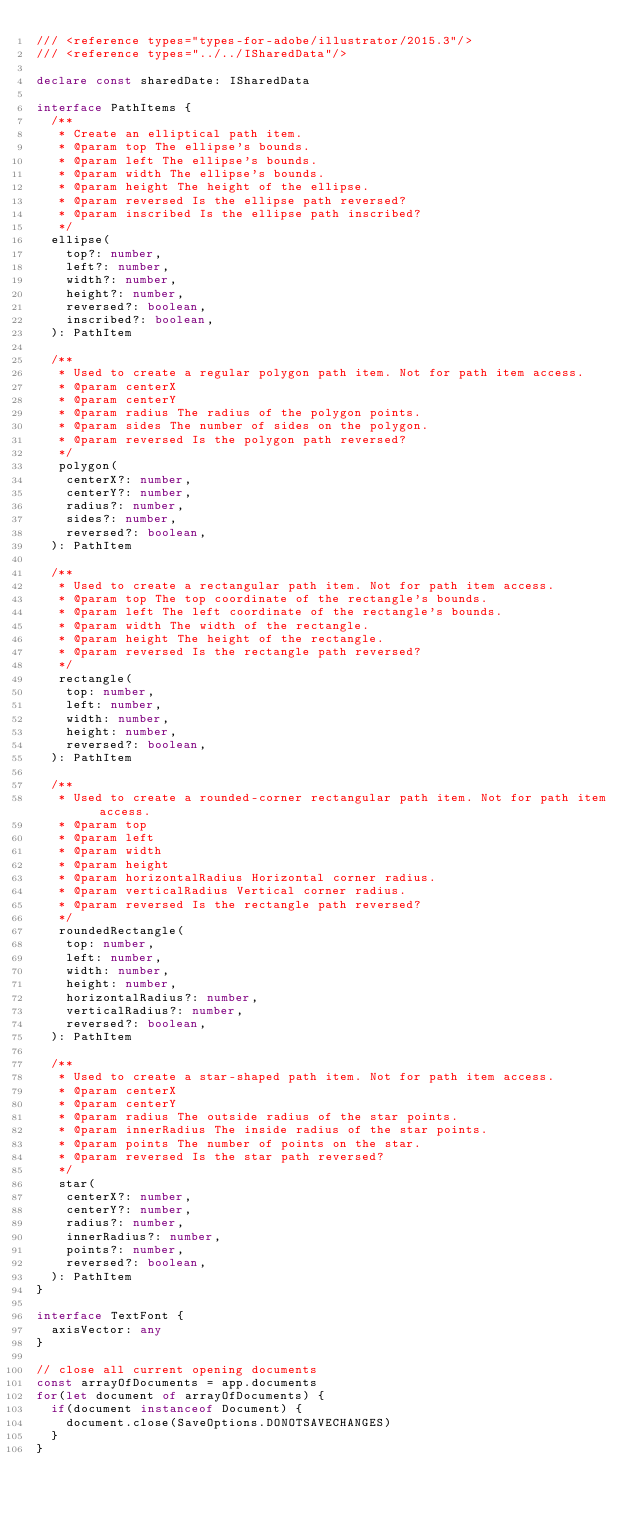<code> <loc_0><loc_0><loc_500><loc_500><_TypeScript_>/// <reference types="types-for-adobe/illustrator/2015.3"/>
/// <reference types="../../ISharedData"/>

declare const sharedDate: ISharedData

interface PathItems {
  /**
   * Create an elliptical path item.
   * @param top The ellipse's bounds.
   * @param left The ellipse's bounds.
   * @param width The ellipse's bounds.
   * @param height The height of the ellipse.
   * @param reversed Is the ellipse path reversed?
   * @param inscribed Is the ellipse path inscribed?
   */
  ellipse(
    top?: number,
    left?: number,
    width?: number,
    height?: number,
    reversed?: boolean,
    inscribed?: boolean,
  ): PathItem

  /**
   * Used to create a regular polygon path item. Not for path item access.
   * @param centerX
   * @param centerY
   * @param radius The radius of the polygon points.
   * @param sides The number of sides on the polygon.
   * @param reversed Is the polygon path reversed?
   */
   polygon(
    centerX?: number,
    centerY?: number,
    radius?: number,
    sides?: number,
    reversed?: boolean,
  ): PathItem

  /**
   * Used to create a rectangular path item. Not for path item access.
   * @param top The top coordinate of the rectangle's bounds.
   * @param left The left coordinate of the rectangle's bounds.
   * @param width The width of the rectangle.
   * @param height The height of the rectangle.
   * @param reversed Is the rectangle path reversed?
   */
   rectangle(
    top: number,
    left: number,
    width: number,
    height: number,
    reversed?: boolean,
  ): PathItem

  /**
   * Used to create a rounded-corner rectangular path item. Not for path item access.
   * @param top
   * @param left
   * @param width
   * @param height
   * @param horizontalRadius Horizontal corner radius.
   * @param verticalRadius Vertical corner radius.
   * @param reversed Is the rectangle path reversed?
   */
   roundedRectangle(
    top: number,
    left: number,
    width: number,
    height: number,
    horizontalRadius?: number,
    verticalRadius?: number,
    reversed?: boolean,
  ): PathItem

  /**
   * Used to create a star-shaped path item. Not for path item access.
   * @param centerX
   * @param centerY
   * @param radius The outside radius of the star points.
   * @param innerRadius The inside radius of the star points.
   * @param points The number of points on the star.
   * @param reversed Is the star path reversed?
   */
   star(
    centerX?: number,
    centerY?: number,
    radius?: number,
    innerRadius?: number,
    points?: number,
    reversed?: boolean,
  ): PathItem
}

interface TextFont {
  axisVector: any
}

// close all current opening documents
const arrayOfDocuments = app.documents
for(let document of arrayOfDocuments) {
  if(document instanceof Document) {
    document.close(SaveOptions.DONOTSAVECHANGES)
  }
}
</code> 